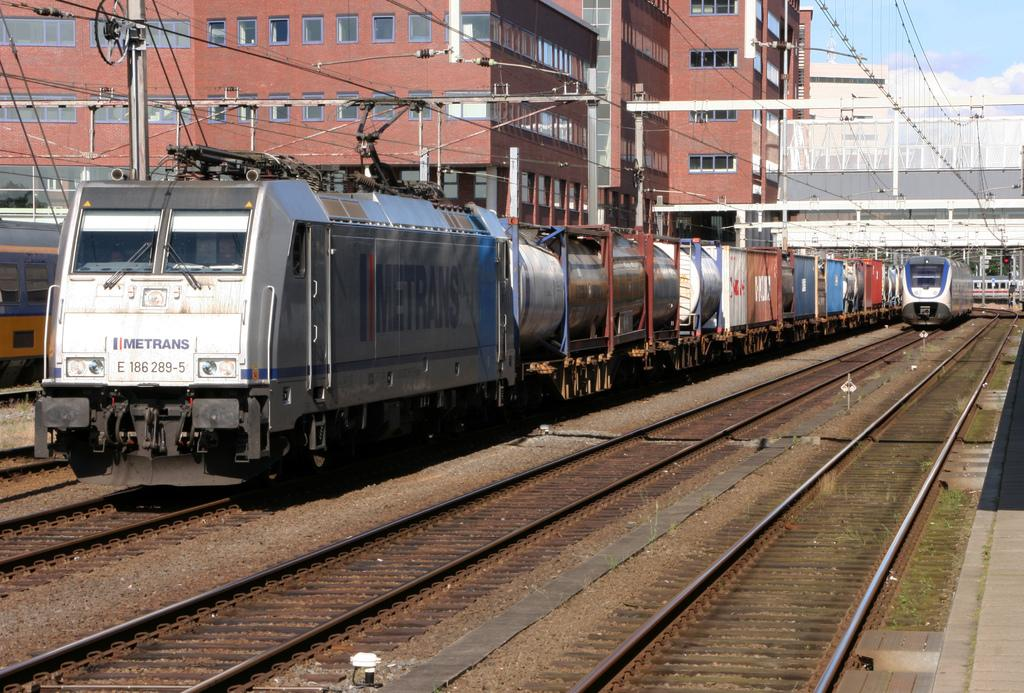<image>
Provide a brief description of the given image. The Metrans train is pulling a number of rail cars behind it as another train approaches alongside. 